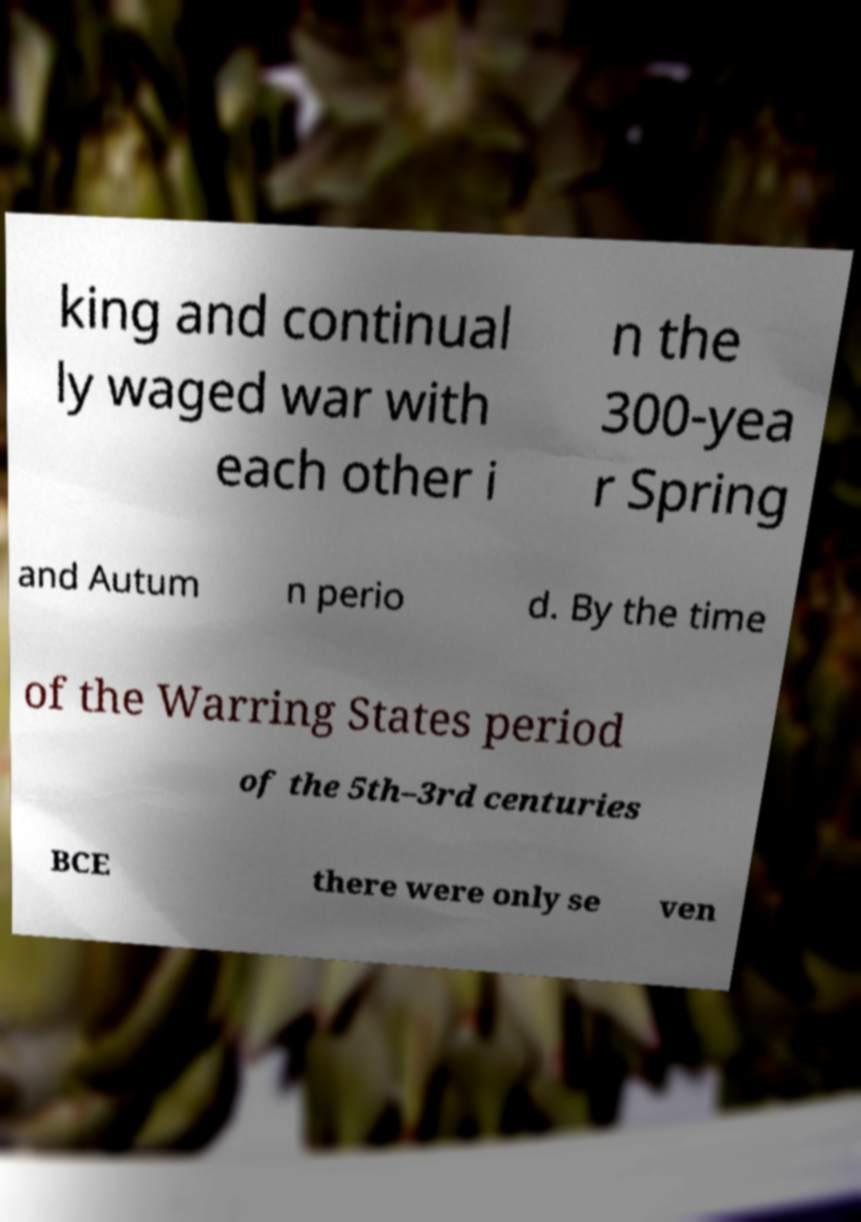What messages or text are displayed in this image? I need them in a readable, typed format. king and continual ly waged war with each other i n the 300-yea r Spring and Autum n perio d. By the time of the Warring States period of the 5th–3rd centuries BCE there were only se ven 